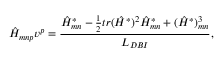<formula> <loc_0><loc_0><loc_500><loc_500>\hat { H } _ { m n p } v ^ { p } = { \frac { \hat { H } _ { m n } ^ { * } - { \frac { 1 } { 2 } } t r ( \hat { H } ^ { * } ) ^ { 2 } \hat { H } _ { m n } ^ { * } + ( \hat { H } ^ { * } ) _ { m n } ^ { 3 } } { L _ { D B I } } } ,</formula> 